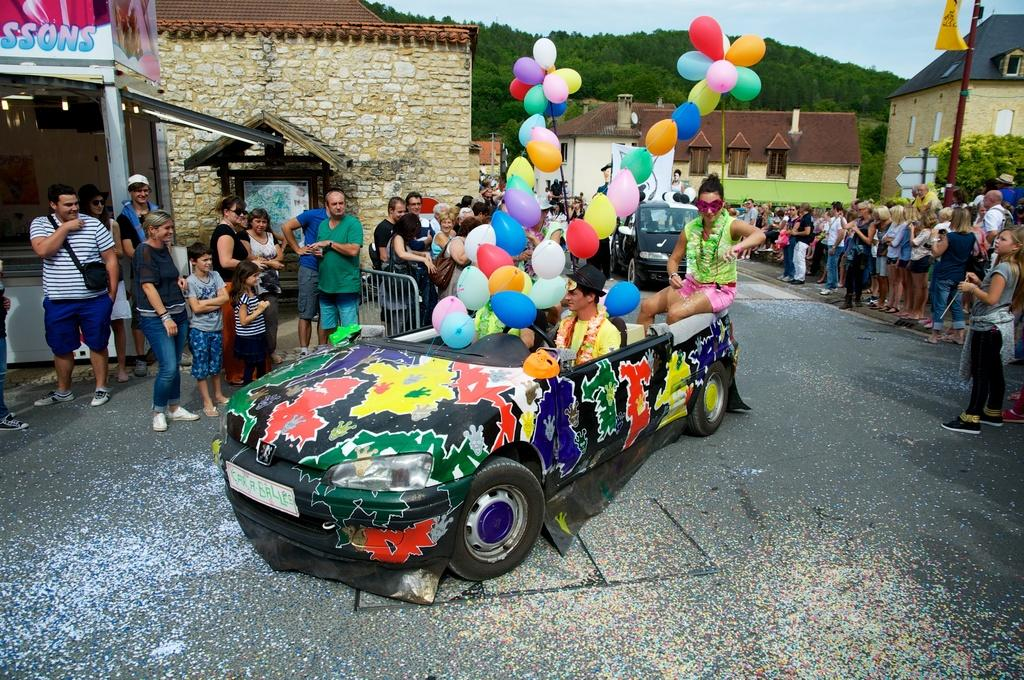How many people are in the group visible in the image? There is a group of people in the image, but the exact number is not specified. What can be seen on the road in the image? Cars are visible on the road in the image. What decorative or festive items are present in the image? Balloons are present in the image. What type of barrier can be seen in the image? There is a fence in the image. What type of temporary structure is present in the image? There is a stall in the image. What is used for displaying information or advertising in the image? A board is visible in the image. What vertical structure can be seen in the image? There is a pole in the image. What type of living organisms are present in the image? Plants are present in the image. What type of permanent structures can be seen in the image? There are houses in the image. What can be seen in the background of the image? Trees and the sky are visible in the background of the image. What type of invention is being demonstrated by the group in the image? There is no invention being demonstrated by the group in the image; it features a group of people, cars, balloons, a fence, a stall, a board, a pole, plants, houses, trees, and the sky. What type of musical instrument is being played by the group in the image? There is no musical instrument being played in the image; it features a group of people, cars, balloons, a fence, a stall, a board, a pole, plants, houses, trees, and the sky. 